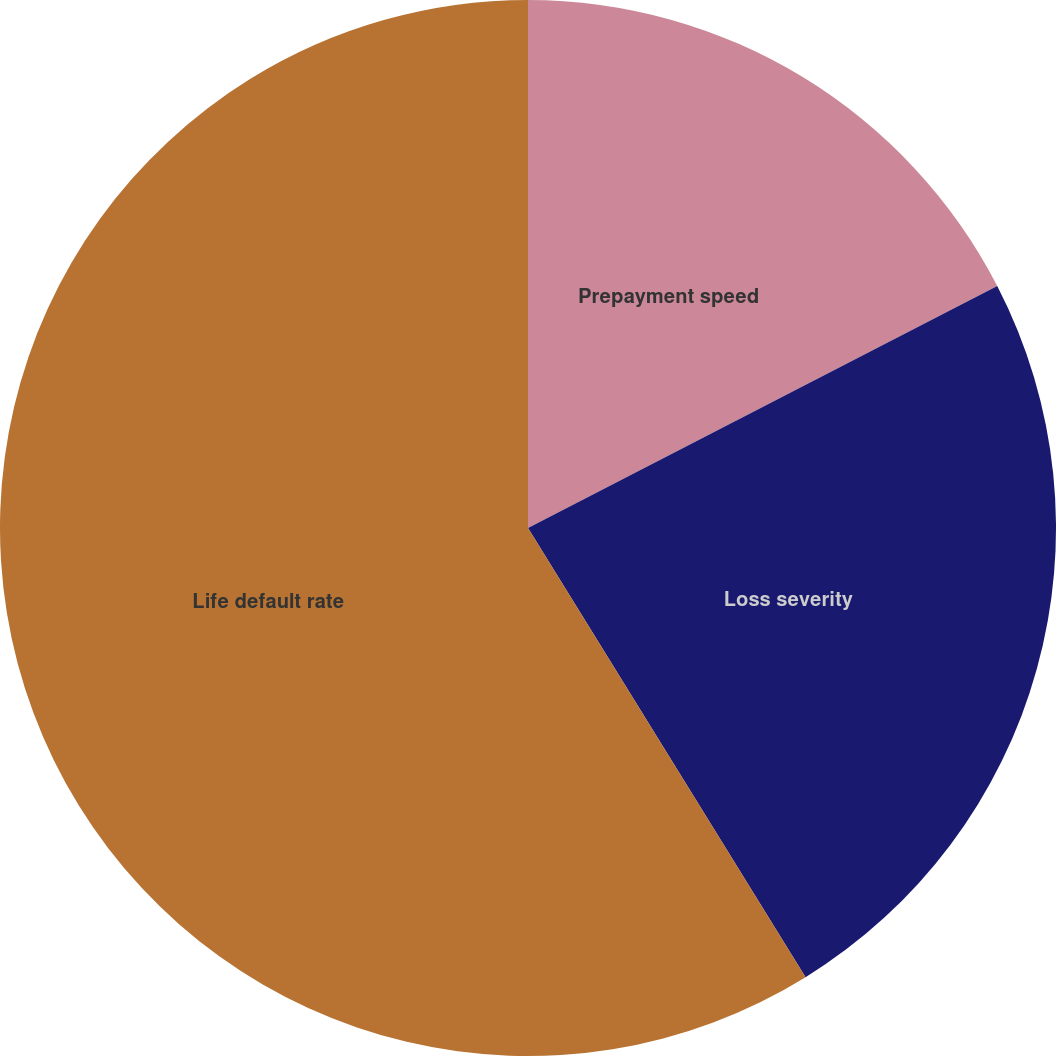Convert chart. <chart><loc_0><loc_0><loc_500><loc_500><pie_chart><fcel>Prepayment speed<fcel>Loss severity<fcel>Life default rate<nl><fcel>17.42%<fcel>23.77%<fcel>58.81%<nl></chart> 